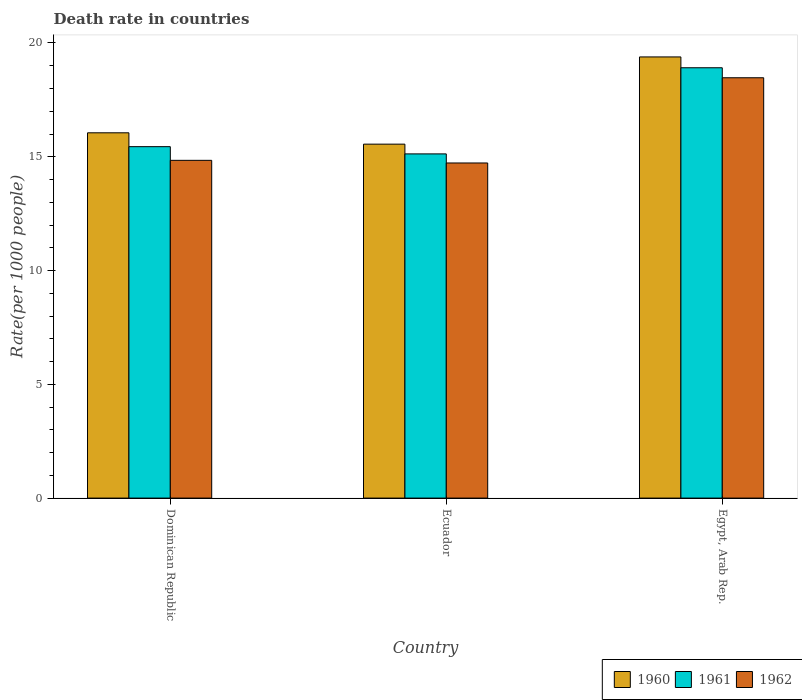How many bars are there on the 2nd tick from the left?
Offer a very short reply. 3. What is the label of the 3rd group of bars from the left?
Provide a short and direct response. Egypt, Arab Rep. In how many cases, is the number of bars for a given country not equal to the number of legend labels?
Provide a short and direct response. 0. What is the death rate in 1962 in Dominican Republic?
Offer a very short reply. 14.84. Across all countries, what is the maximum death rate in 1961?
Provide a short and direct response. 18.91. Across all countries, what is the minimum death rate in 1961?
Your answer should be very brief. 15.13. In which country was the death rate in 1960 maximum?
Ensure brevity in your answer.  Egypt, Arab Rep. In which country was the death rate in 1962 minimum?
Offer a very short reply. Ecuador. What is the total death rate in 1961 in the graph?
Provide a succinct answer. 49.48. What is the difference between the death rate in 1960 in Dominican Republic and that in Ecuador?
Provide a succinct answer. 0.5. What is the difference between the death rate in 1960 in Ecuador and the death rate in 1961 in Egypt, Arab Rep.?
Provide a short and direct response. -3.36. What is the average death rate in 1961 per country?
Offer a terse response. 16.49. What is the difference between the death rate of/in 1962 and death rate of/in 1961 in Dominican Republic?
Your answer should be very brief. -0.6. What is the ratio of the death rate in 1962 in Dominican Republic to that in Ecuador?
Offer a very short reply. 1.01. Is the difference between the death rate in 1962 in Ecuador and Egypt, Arab Rep. greater than the difference between the death rate in 1961 in Ecuador and Egypt, Arab Rep.?
Give a very brief answer. Yes. What is the difference between the highest and the second highest death rate in 1960?
Make the answer very short. -3.33. What is the difference between the highest and the lowest death rate in 1961?
Offer a terse response. 3.79. In how many countries, is the death rate in 1962 greater than the average death rate in 1962 taken over all countries?
Offer a terse response. 1. What does the 3rd bar from the right in Dominican Republic represents?
Keep it short and to the point. 1960. How many countries are there in the graph?
Your response must be concise. 3. What is the difference between two consecutive major ticks on the Y-axis?
Give a very brief answer. 5. Does the graph contain any zero values?
Your answer should be very brief. No. What is the title of the graph?
Provide a succinct answer. Death rate in countries. What is the label or title of the X-axis?
Offer a very short reply. Country. What is the label or title of the Y-axis?
Keep it short and to the point. Rate(per 1000 people). What is the Rate(per 1000 people) of 1960 in Dominican Republic?
Make the answer very short. 16.05. What is the Rate(per 1000 people) in 1961 in Dominican Republic?
Provide a short and direct response. 15.44. What is the Rate(per 1000 people) of 1962 in Dominican Republic?
Give a very brief answer. 14.84. What is the Rate(per 1000 people) of 1960 in Ecuador?
Ensure brevity in your answer.  15.55. What is the Rate(per 1000 people) in 1961 in Ecuador?
Give a very brief answer. 15.13. What is the Rate(per 1000 people) in 1962 in Ecuador?
Keep it short and to the point. 14.73. What is the Rate(per 1000 people) in 1960 in Egypt, Arab Rep.?
Provide a short and direct response. 19.39. What is the Rate(per 1000 people) in 1961 in Egypt, Arab Rep.?
Keep it short and to the point. 18.91. What is the Rate(per 1000 people) in 1962 in Egypt, Arab Rep.?
Your response must be concise. 18.47. Across all countries, what is the maximum Rate(per 1000 people) of 1960?
Your answer should be very brief. 19.39. Across all countries, what is the maximum Rate(per 1000 people) of 1961?
Your response must be concise. 18.91. Across all countries, what is the maximum Rate(per 1000 people) of 1962?
Make the answer very short. 18.47. Across all countries, what is the minimum Rate(per 1000 people) of 1960?
Offer a very short reply. 15.55. Across all countries, what is the minimum Rate(per 1000 people) of 1961?
Offer a terse response. 15.13. Across all countries, what is the minimum Rate(per 1000 people) of 1962?
Provide a succinct answer. 14.73. What is the total Rate(per 1000 people) of 1960 in the graph?
Your response must be concise. 50.99. What is the total Rate(per 1000 people) in 1961 in the graph?
Your answer should be compact. 49.48. What is the total Rate(per 1000 people) in 1962 in the graph?
Give a very brief answer. 48.04. What is the difference between the Rate(per 1000 people) of 1960 in Dominican Republic and that in Ecuador?
Provide a succinct answer. 0.5. What is the difference between the Rate(per 1000 people) in 1961 in Dominican Republic and that in Ecuador?
Ensure brevity in your answer.  0.32. What is the difference between the Rate(per 1000 people) of 1962 in Dominican Republic and that in Ecuador?
Ensure brevity in your answer.  0.12. What is the difference between the Rate(per 1000 people) of 1960 in Dominican Republic and that in Egypt, Arab Rep.?
Offer a terse response. -3.33. What is the difference between the Rate(per 1000 people) in 1961 in Dominican Republic and that in Egypt, Arab Rep.?
Your response must be concise. -3.47. What is the difference between the Rate(per 1000 people) of 1962 in Dominican Republic and that in Egypt, Arab Rep.?
Keep it short and to the point. -3.63. What is the difference between the Rate(per 1000 people) in 1960 in Ecuador and that in Egypt, Arab Rep.?
Provide a succinct answer. -3.83. What is the difference between the Rate(per 1000 people) in 1961 in Ecuador and that in Egypt, Arab Rep.?
Provide a short and direct response. -3.79. What is the difference between the Rate(per 1000 people) in 1962 in Ecuador and that in Egypt, Arab Rep.?
Provide a short and direct response. -3.75. What is the difference between the Rate(per 1000 people) in 1960 in Dominican Republic and the Rate(per 1000 people) in 1961 in Ecuador?
Provide a short and direct response. 0.93. What is the difference between the Rate(per 1000 people) of 1960 in Dominican Republic and the Rate(per 1000 people) of 1962 in Ecuador?
Keep it short and to the point. 1.33. What is the difference between the Rate(per 1000 people) in 1961 in Dominican Republic and the Rate(per 1000 people) in 1962 in Ecuador?
Keep it short and to the point. 0.72. What is the difference between the Rate(per 1000 people) of 1960 in Dominican Republic and the Rate(per 1000 people) of 1961 in Egypt, Arab Rep.?
Offer a very short reply. -2.86. What is the difference between the Rate(per 1000 people) in 1960 in Dominican Republic and the Rate(per 1000 people) in 1962 in Egypt, Arab Rep.?
Offer a terse response. -2.42. What is the difference between the Rate(per 1000 people) in 1961 in Dominican Republic and the Rate(per 1000 people) in 1962 in Egypt, Arab Rep.?
Give a very brief answer. -3.03. What is the difference between the Rate(per 1000 people) of 1960 in Ecuador and the Rate(per 1000 people) of 1961 in Egypt, Arab Rep.?
Provide a short and direct response. -3.36. What is the difference between the Rate(per 1000 people) of 1960 in Ecuador and the Rate(per 1000 people) of 1962 in Egypt, Arab Rep.?
Your answer should be compact. -2.92. What is the difference between the Rate(per 1000 people) in 1961 in Ecuador and the Rate(per 1000 people) in 1962 in Egypt, Arab Rep.?
Offer a terse response. -3.35. What is the average Rate(per 1000 people) in 1960 per country?
Give a very brief answer. 17. What is the average Rate(per 1000 people) in 1961 per country?
Offer a very short reply. 16.49. What is the average Rate(per 1000 people) in 1962 per country?
Your response must be concise. 16.01. What is the difference between the Rate(per 1000 people) of 1960 and Rate(per 1000 people) of 1961 in Dominican Republic?
Offer a terse response. 0.61. What is the difference between the Rate(per 1000 people) in 1960 and Rate(per 1000 people) in 1962 in Dominican Republic?
Provide a short and direct response. 1.21. What is the difference between the Rate(per 1000 people) in 1961 and Rate(per 1000 people) in 1962 in Dominican Republic?
Keep it short and to the point. 0.6. What is the difference between the Rate(per 1000 people) in 1960 and Rate(per 1000 people) in 1961 in Ecuador?
Give a very brief answer. 0.43. What is the difference between the Rate(per 1000 people) in 1960 and Rate(per 1000 people) in 1962 in Ecuador?
Keep it short and to the point. 0.83. What is the difference between the Rate(per 1000 people) in 1961 and Rate(per 1000 people) in 1962 in Ecuador?
Provide a succinct answer. 0.4. What is the difference between the Rate(per 1000 people) of 1960 and Rate(per 1000 people) of 1961 in Egypt, Arab Rep.?
Make the answer very short. 0.48. What is the difference between the Rate(per 1000 people) in 1960 and Rate(per 1000 people) in 1962 in Egypt, Arab Rep.?
Offer a very short reply. 0.92. What is the difference between the Rate(per 1000 people) in 1961 and Rate(per 1000 people) in 1962 in Egypt, Arab Rep.?
Your answer should be very brief. 0.44. What is the ratio of the Rate(per 1000 people) of 1960 in Dominican Republic to that in Ecuador?
Keep it short and to the point. 1.03. What is the ratio of the Rate(per 1000 people) in 1961 in Dominican Republic to that in Ecuador?
Keep it short and to the point. 1.02. What is the ratio of the Rate(per 1000 people) in 1962 in Dominican Republic to that in Ecuador?
Offer a terse response. 1.01. What is the ratio of the Rate(per 1000 people) of 1960 in Dominican Republic to that in Egypt, Arab Rep.?
Offer a very short reply. 0.83. What is the ratio of the Rate(per 1000 people) in 1961 in Dominican Republic to that in Egypt, Arab Rep.?
Ensure brevity in your answer.  0.82. What is the ratio of the Rate(per 1000 people) in 1962 in Dominican Republic to that in Egypt, Arab Rep.?
Your answer should be very brief. 0.8. What is the ratio of the Rate(per 1000 people) in 1960 in Ecuador to that in Egypt, Arab Rep.?
Make the answer very short. 0.8. What is the ratio of the Rate(per 1000 people) of 1961 in Ecuador to that in Egypt, Arab Rep.?
Offer a very short reply. 0.8. What is the ratio of the Rate(per 1000 people) of 1962 in Ecuador to that in Egypt, Arab Rep.?
Provide a short and direct response. 0.8. What is the difference between the highest and the second highest Rate(per 1000 people) in 1960?
Offer a very short reply. 3.33. What is the difference between the highest and the second highest Rate(per 1000 people) of 1961?
Provide a short and direct response. 3.47. What is the difference between the highest and the second highest Rate(per 1000 people) in 1962?
Provide a succinct answer. 3.63. What is the difference between the highest and the lowest Rate(per 1000 people) in 1960?
Offer a terse response. 3.83. What is the difference between the highest and the lowest Rate(per 1000 people) of 1961?
Offer a very short reply. 3.79. What is the difference between the highest and the lowest Rate(per 1000 people) of 1962?
Provide a short and direct response. 3.75. 